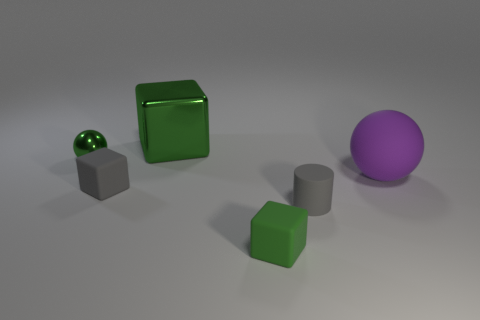Do the purple thing and the small green sphere have the same material? From the image, it appears that the purple object, which seems to be a large ball, and the small green sphere may have different materials. The green sphere has a highly reflective, almost glass-like surface, suggesting it could be made of polished stone or a glossy synthetic. In contrast, the purple ball, while also displaying reflectivity, has a less intense sheen that could be indicative of a matte or slightly textured finish. Without further tactile or physical analysis, it's difficult to determine with absolute certainty, but visually, they seem to have distinct material properties. 